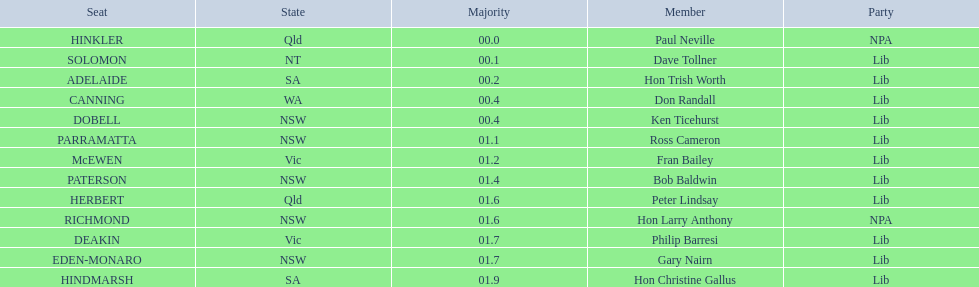Who are all the lib party members? Dave Tollner, Hon Trish Worth, Don Randall, Ken Ticehurst, Ross Cameron, Fran Bailey, Bob Baldwin, Peter Lindsay, Philip Barresi, Gary Nairn, Hon Christine Gallus. What lib party members are in sa? Hon Trish Worth, Hon Christine Gallus. What is the highest difference in majority between members in sa? 01.9. 